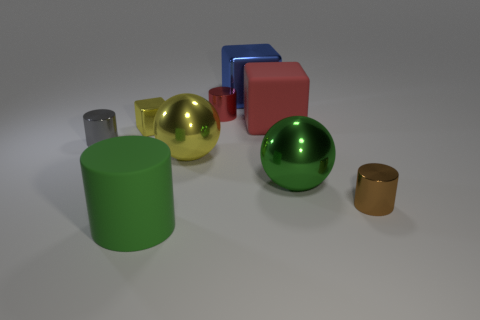Do the matte thing to the left of the red metal cylinder and the big shiny cube have the same color?
Give a very brief answer. No. Is there a metal thing of the same color as the large rubber cylinder?
Make the answer very short. Yes. What number of tiny shiny objects are on the right side of the yellow shiny sphere?
Make the answer very short. 2. How many other things are the same size as the red rubber object?
Make the answer very short. 4. Is the big ball on the left side of the red metallic cylinder made of the same material as the green object behind the small brown metal thing?
Your answer should be very brief. Yes. There is a matte object that is the same size as the red cube; what color is it?
Offer a very short reply. Green. Is there anything else of the same color as the big metallic block?
Make the answer very short. No. What size is the rubber object left of the tiny metal cylinder behind the metallic block that is in front of the big blue cube?
Keep it short and to the point. Large. There is a shiny cylinder that is both in front of the big red cube and on the left side of the green metal ball; what color is it?
Offer a terse response. Gray. How big is the rubber object behind the yellow metallic block?
Your response must be concise. Large. 